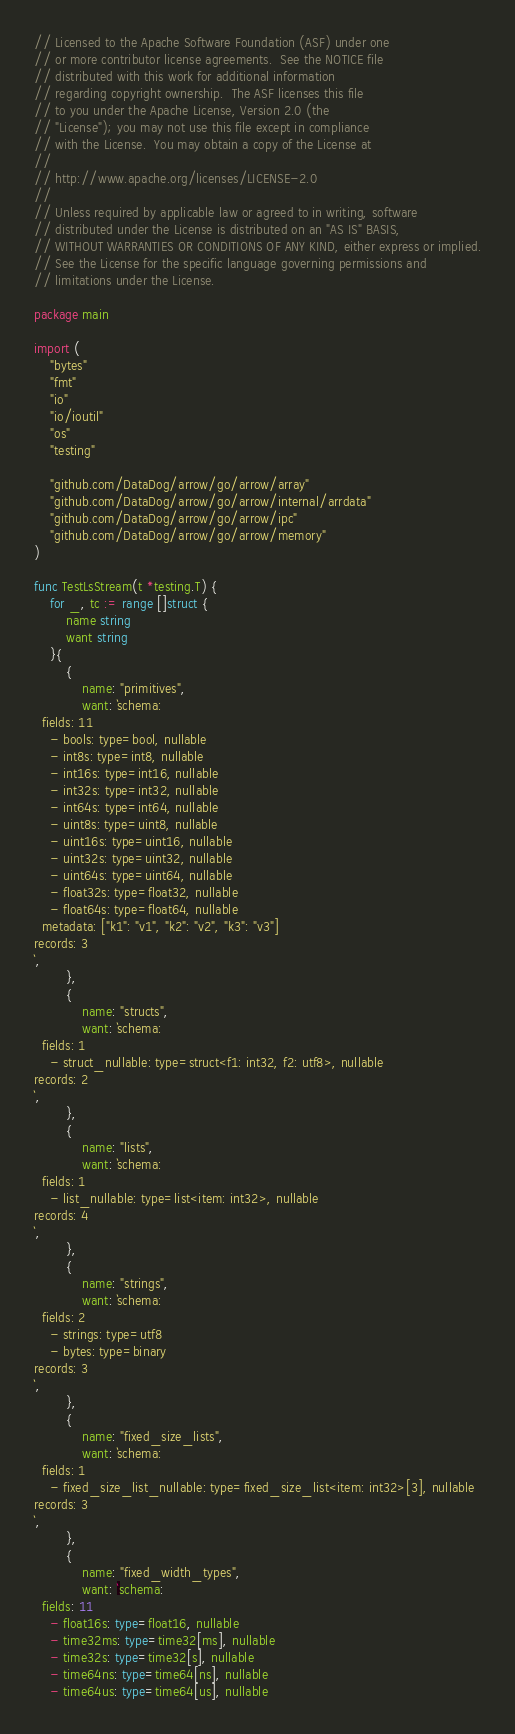<code> <loc_0><loc_0><loc_500><loc_500><_Go_>// Licensed to the Apache Software Foundation (ASF) under one
// or more contributor license agreements.  See the NOTICE file
// distributed with this work for additional information
// regarding copyright ownership.  The ASF licenses this file
// to you under the Apache License, Version 2.0 (the
// "License"); you may not use this file except in compliance
// with the License.  You may obtain a copy of the License at
//
// http://www.apache.org/licenses/LICENSE-2.0
//
// Unless required by applicable law or agreed to in writing, software
// distributed under the License is distributed on an "AS IS" BASIS,
// WITHOUT WARRANTIES OR CONDITIONS OF ANY KIND, either express or implied.
// See the License for the specific language governing permissions and
// limitations under the License.

package main

import (
	"bytes"
	"fmt"
	"io"
	"io/ioutil"
	"os"
	"testing"

	"github.com/DataDog/arrow/go/arrow/array"
	"github.com/DataDog/arrow/go/arrow/internal/arrdata"
	"github.com/DataDog/arrow/go/arrow/ipc"
	"github.com/DataDog/arrow/go/arrow/memory"
)

func TestLsStream(t *testing.T) {
	for _, tc := range []struct {
		name string
		want string
	}{
		{
			name: "primitives",
			want: `schema:
  fields: 11
    - bools: type=bool, nullable
    - int8s: type=int8, nullable
    - int16s: type=int16, nullable
    - int32s: type=int32, nullable
    - int64s: type=int64, nullable
    - uint8s: type=uint8, nullable
    - uint16s: type=uint16, nullable
    - uint32s: type=uint32, nullable
    - uint64s: type=uint64, nullable
    - float32s: type=float32, nullable
    - float64s: type=float64, nullable
  metadata: ["k1": "v1", "k2": "v2", "k3": "v3"]
records: 3
`,
		},
		{
			name: "structs",
			want: `schema:
  fields: 1
    - struct_nullable: type=struct<f1: int32, f2: utf8>, nullable
records: 2
`,
		},
		{
			name: "lists",
			want: `schema:
  fields: 1
    - list_nullable: type=list<item: int32>, nullable
records: 4
`,
		},
		{
			name: "strings",
			want: `schema:
  fields: 2
    - strings: type=utf8
    - bytes: type=binary
records: 3
`,
		},
		{
			name: "fixed_size_lists",
			want: `schema:
  fields: 1
    - fixed_size_list_nullable: type=fixed_size_list<item: int32>[3], nullable
records: 3
`,
		},
		{
			name: "fixed_width_types",
			want: `schema:
  fields: 11
    - float16s: type=float16, nullable
    - time32ms: type=time32[ms], nullable
    - time32s: type=time32[s], nullable
    - time64ns: type=time64[ns], nullable
    - time64us: type=time64[us], nullable</code> 